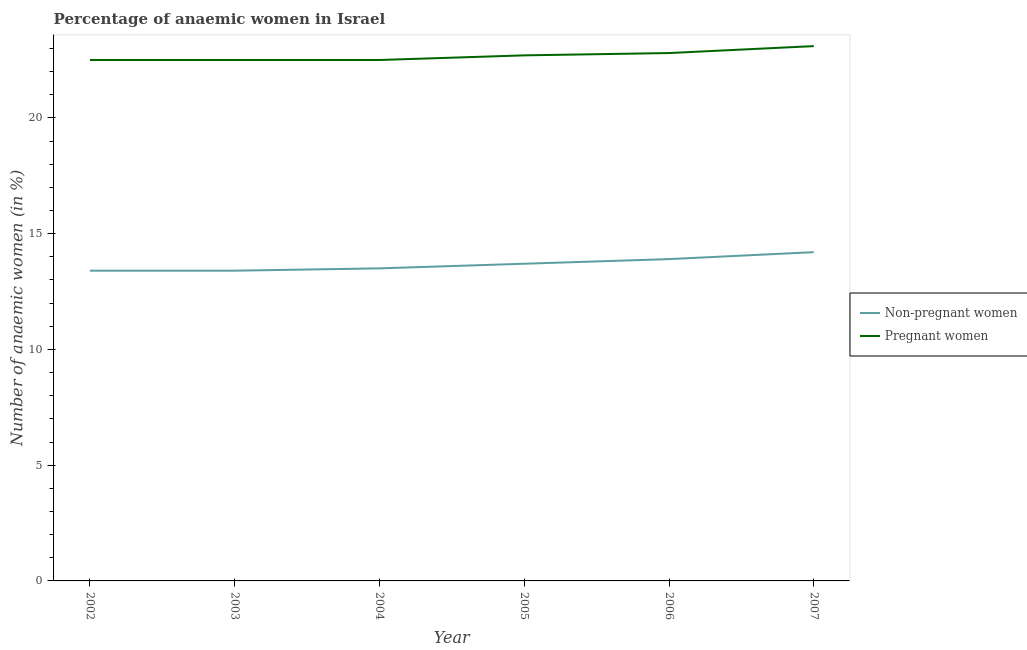How many different coloured lines are there?
Keep it short and to the point. 2. Is the number of lines equal to the number of legend labels?
Provide a succinct answer. Yes. What is the percentage of pregnant anaemic women in 2005?
Provide a short and direct response. 22.7. Across all years, what is the maximum percentage of non-pregnant anaemic women?
Offer a terse response. 14.2. Across all years, what is the minimum percentage of pregnant anaemic women?
Give a very brief answer. 22.5. In which year was the percentage of pregnant anaemic women maximum?
Keep it short and to the point. 2007. In which year was the percentage of pregnant anaemic women minimum?
Ensure brevity in your answer.  2002. What is the total percentage of pregnant anaemic women in the graph?
Give a very brief answer. 136.1. What is the difference between the percentage of pregnant anaemic women in 2002 and that in 2007?
Make the answer very short. -0.6. What is the average percentage of non-pregnant anaemic women per year?
Give a very brief answer. 13.68. What is the ratio of the percentage of pregnant anaemic women in 2005 to that in 2007?
Give a very brief answer. 0.98. Is the difference between the percentage of pregnant anaemic women in 2006 and 2007 greater than the difference between the percentage of non-pregnant anaemic women in 2006 and 2007?
Ensure brevity in your answer.  No. What is the difference between the highest and the second highest percentage of non-pregnant anaemic women?
Provide a succinct answer. 0.3. What is the difference between the highest and the lowest percentage of non-pregnant anaemic women?
Your answer should be compact. 0.8. Does the percentage of non-pregnant anaemic women monotonically increase over the years?
Your answer should be very brief. No. Is the percentage of pregnant anaemic women strictly greater than the percentage of non-pregnant anaemic women over the years?
Your response must be concise. Yes. How many lines are there?
Your answer should be very brief. 2. How many years are there in the graph?
Keep it short and to the point. 6. Does the graph contain any zero values?
Provide a succinct answer. No. Does the graph contain grids?
Your answer should be compact. No. Where does the legend appear in the graph?
Give a very brief answer. Center right. How many legend labels are there?
Your answer should be compact. 2. What is the title of the graph?
Make the answer very short. Percentage of anaemic women in Israel. What is the label or title of the Y-axis?
Your answer should be very brief. Number of anaemic women (in %). What is the Number of anaemic women (in %) of Non-pregnant women in 2002?
Offer a very short reply. 13.4. What is the Number of anaemic women (in %) in Non-pregnant women in 2004?
Make the answer very short. 13.5. What is the Number of anaemic women (in %) of Non-pregnant women in 2005?
Provide a succinct answer. 13.7. What is the Number of anaemic women (in %) of Pregnant women in 2005?
Provide a succinct answer. 22.7. What is the Number of anaemic women (in %) in Non-pregnant women in 2006?
Your answer should be very brief. 13.9. What is the Number of anaemic women (in %) in Pregnant women in 2006?
Provide a short and direct response. 22.8. What is the Number of anaemic women (in %) in Non-pregnant women in 2007?
Give a very brief answer. 14.2. What is the Number of anaemic women (in %) of Pregnant women in 2007?
Give a very brief answer. 23.1. Across all years, what is the maximum Number of anaemic women (in %) of Non-pregnant women?
Offer a very short reply. 14.2. Across all years, what is the maximum Number of anaemic women (in %) in Pregnant women?
Your response must be concise. 23.1. Across all years, what is the minimum Number of anaemic women (in %) in Pregnant women?
Your answer should be very brief. 22.5. What is the total Number of anaemic women (in %) of Non-pregnant women in the graph?
Your answer should be very brief. 82.1. What is the total Number of anaemic women (in %) in Pregnant women in the graph?
Offer a terse response. 136.1. What is the difference between the Number of anaemic women (in %) in Non-pregnant women in 2002 and that in 2003?
Make the answer very short. 0. What is the difference between the Number of anaemic women (in %) of Pregnant women in 2002 and that in 2003?
Give a very brief answer. 0. What is the difference between the Number of anaemic women (in %) in Non-pregnant women in 2002 and that in 2005?
Provide a short and direct response. -0.3. What is the difference between the Number of anaemic women (in %) of Pregnant women in 2002 and that in 2006?
Offer a very short reply. -0.3. What is the difference between the Number of anaemic women (in %) in Pregnant women in 2002 and that in 2007?
Ensure brevity in your answer.  -0.6. What is the difference between the Number of anaemic women (in %) of Non-pregnant women in 2003 and that in 2004?
Your answer should be compact. -0.1. What is the difference between the Number of anaemic women (in %) of Non-pregnant women in 2003 and that in 2005?
Your response must be concise. -0.3. What is the difference between the Number of anaemic women (in %) of Non-pregnant women in 2003 and that in 2007?
Offer a very short reply. -0.8. What is the difference between the Number of anaemic women (in %) in Pregnant women in 2003 and that in 2007?
Provide a succinct answer. -0.6. What is the difference between the Number of anaemic women (in %) in Non-pregnant women in 2004 and that in 2005?
Give a very brief answer. -0.2. What is the difference between the Number of anaemic women (in %) of Pregnant women in 2004 and that in 2005?
Provide a succinct answer. -0.2. What is the difference between the Number of anaemic women (in %) of Non-pregnant women in 2004 and that in 2006?
Offer a very short reply. -0.4. What is the difference between the Number of anaemic women (in %) in Pregnant women in 2004 and that in 2006?
Offer a terse response. -0.3. What is the difference between the Number of anaemic women (in %) in Pregnant women in 2004 and that in 2007?
Your answer should be compact. -0.6. What is the difference between the Number of anaemic women (in %) of Non-pregnant women in 2005 and that in 2006?
Make the answer very short. -0.2. What is the difference between the Number of anaemic women (in %) of Pregnant women in 2005 and that in 2006?
Your answer should be compact. -0.1. What is the difference between the Number of anaemic women (in %) in Non-pregnant women in 2006 and that in 2007?
Keep it short and to the point. -0.3. What is the difference between the Number of anaemic women (in %) in Pregnant women in 2006 and that in 2007?
Provide a short and direct response. -0.3. What is the difference between the Number of anaemic women (in %) in Non-pregnant women in 2003 and the Number of anaemic women (in %) in Pregnant women in 2006?
Your answer should be very brief. -9.4. What is the difference between the Number of anaemic women (in %) in Non-pregnant women in 2003 and the Number of anaemic women (in %) in Pregnant women in 2007?
Your response must be concise. -9.7. What is the difference between the Number of anaemic women (in %) of Non-pregnant women in 2004 and the Number of anaemic women (in %) of Pregnant women in 2006?
Keep it short and to the point. -9.3. What is the difference between the Number of anaemic women (in %) of Non-pregnant women in 2004 and the Number of anaemic women (in %) of Pregnant women in 2007?
Give a very brief answer. -9.6. What is the difference between the Number of anaemic women (in %) in Non-pregnant women in 2005 and the Number of anaemic women (in %) in Pregnant women in 2006?
Give a very brief answer. -9.1. What is the average Number of anaemic women (in %) in Non-pregnant women per year?
Your answer should be very brief. 13.68. What is the average Number of anaemic women (in %) of Pregnant women per year?
Ensure brevity in your answer.  22.68. In the year 2002, what is the difference between the Number of anaemic women (in %) in Non-pregnant women and Number of anaemic women (in %) in Pregnant women?
Your response must be concise. -9.1. In the year 2004, what is the difference between the Number of anaemic women (in %) of Non-pregnant women and Number of anaemic women (in %) of Pregnant women?
Offer a terse response. -9. In the year 2006, what is the difference between the Number of anaemic women (in %) of Non-pregnant women and Number of anaemic women (in %) of Pregnant women?
Provide a succinct answer. -8.9. What is the ratio of the Number of anaemic women (in %) in Pregnant women in 2002 to that in 2003?
Provide a succinct answer. 1. What is the ratio of the Number of anaemic women (in %) in Pregnant women in 2002 to that in 2004?
Ensure brevity in your answer.  1. What is the ratio of the Number of anaemic women (in %) of Non-pregnant women in 2002 to that in 2005?
Give a very brief answer. 0.98. What is the ratio of the Number of anaemic women (in %) in Pregnant women in 2002 to that in 2006?
Provide a short and direct response. 0.99. What is the ratio of the Number of anaemic women (in %) in Non-pregnant women in 2002 to that in 2007?
Ensure brevity in your answer.  0.94. What is the ratio of the Number of anaemic women (in %) of Pregnant women in 2002 to that in 2007?
Your response must be concise. 0.97. What is the ratio of the Number of anaemic women (in %) of Non-pregnant women in 2003 to that in 2004?
Your answer should be compact. 0.99. What is the ratio of the Number of anaemic women (in %) of Non-pregnant women in 2003 to that in 2005?
Offer a terse response. 0.98. What is the ratio of the Number of anaemic women (in %) in Non-pregnant women in 2003 to that in 2006?
Your answer should be compact. 0.96. What is the ratio of the Number of anaemic women (in %) of Non-pregnant women in 2003 to that in 2007?
Make the answer very short. 0.94. What is the ratio of the Number of anaemic women (in %) of Non-pregnant women in 2004 to that in 2005?
Your answer should be compact. 0.99. What is the ratio of the Number of anaemic women (in %) of Pregnant women in 2004 to that in 2005?
Provide a succinct answer. 0.99. What is the ratio of the Number of anaemic women (in %) in Non-pregnant women in 2004 to that in 2006?
Your response must be concise. 0.97. What is the ratio of the Number of anaemic women (in %) of Non-pregnant women in 2004 to that in 2007?
Provide a succinct answer. 0.95. What is the ratio of the Number of anaemic women (in %) in Non-pregnant women in 2005 to that in 2006?
Give a very brief answer. 0.99. What is the ratio of the Number of anaemic women (in %) in Pregnant women in 2005 to that in 2006?
Your answer should be compact. 1. What is the ratio of the Number of anaemic women (in %) of Non-pregnant women in 2005 to that in 2007?
Give a very brief answer. 0.96. What is the ratio of the Number of anaemic women (in %) in Pregnant women in 2005 to that in 2007?
Your response must be concise. 0.98. What is the ratio of the Number of anaemic women (in %) in Non-pregnant women in 2006 to that in 2007?
Give a very brief answer. 0.98. What is the difference between the highest and the second highest Number of anaemic women (in %) in Non-pregnant women?
Give a very brief answer. 0.3. What is the difference between the highest and the second highest Number of anaemic women (in %) in Pregnant women?
Offer a very short reply. 0.3. What is the difference between the highest and the lowest Number of anaemic women (in %) of Non-pregnant women?
Your answer should be very brief. 0.8. 